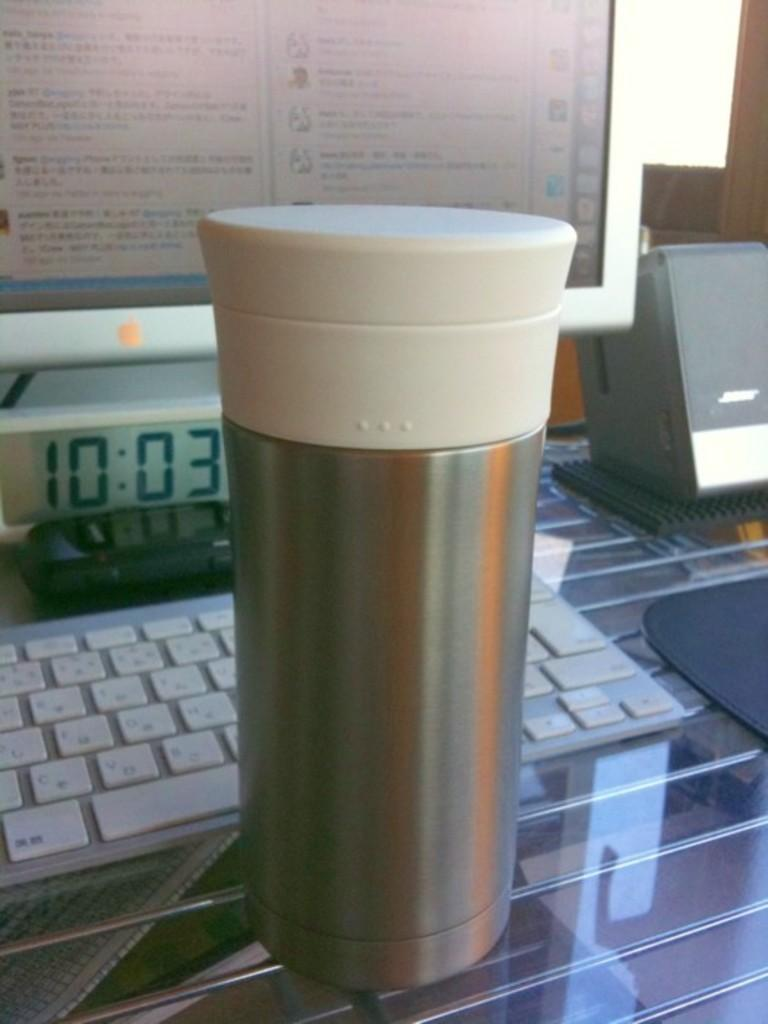What is the main object in the image? There is a container in the image. What can be seen in the background of the image? There is a keyboard, a monitor, and other objects in the background of the image. What type of surface is at the bottom of the image? There is a glass surface at the bottom of the image. How does the wind affect the wing of the bird in the image? There is no bird or wing present in the image; it only features a container, a keyboard, a monitor, and other objects in the background. 